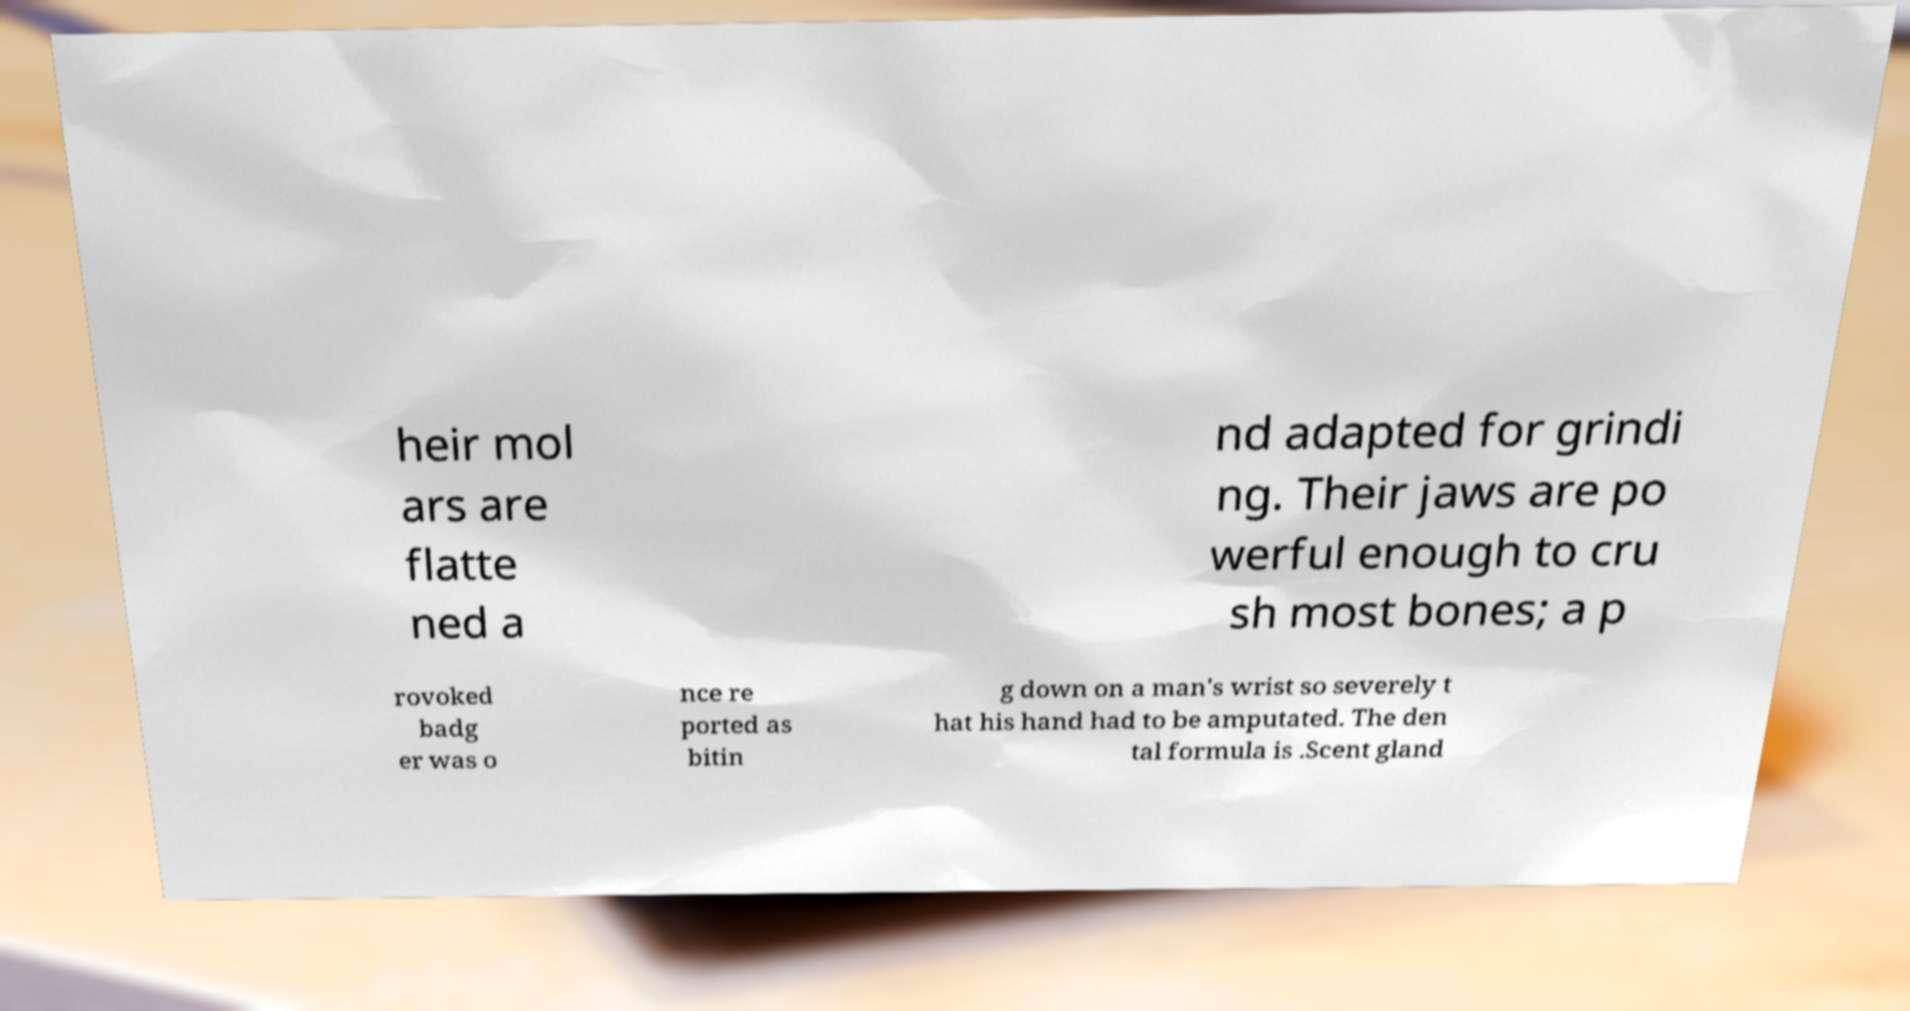There's text embedded in this image that I need extracted. Can you transcribe it verbatim? heir mol ars are flatte ned a nd adapted for grindi ng. Their jaws are po werful enough to cru sh most bones; a p rovoked badg er was o nce re ported as bitin g down on a man's wrist so severely t hat his hand had to be amputated. The den tal formula is .Scent gland 